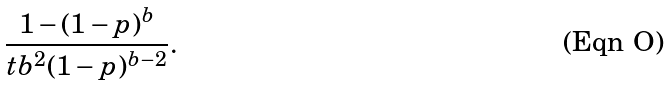<formula> <loc_0><loc_0><loc_500><loc_500>\frac { 1 - ( 1 - p ) ^ { b } } { t b ^ { 2 } ( 1 - p ) ^ { b - 2 } } .</formula> 